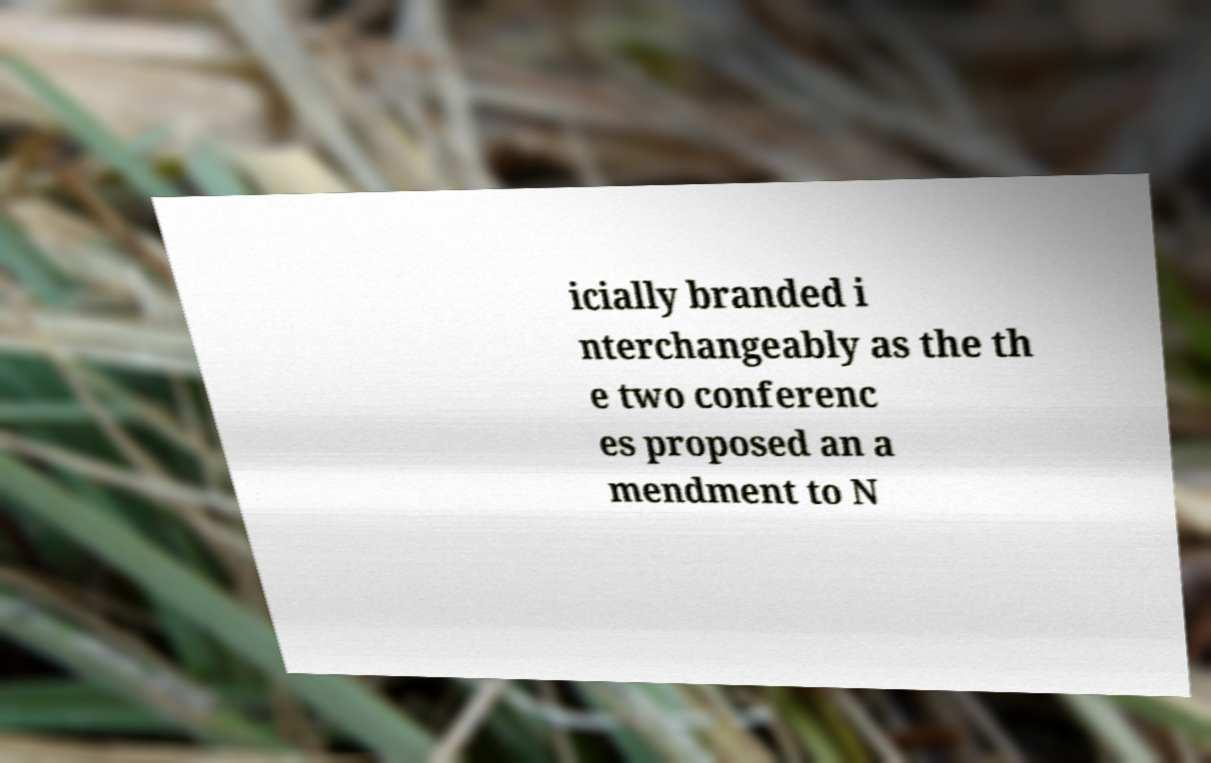Could you extract and type out the text from this image? icially branded i nterchangeably as the th e two conferenc es proposed an a mendment to N 